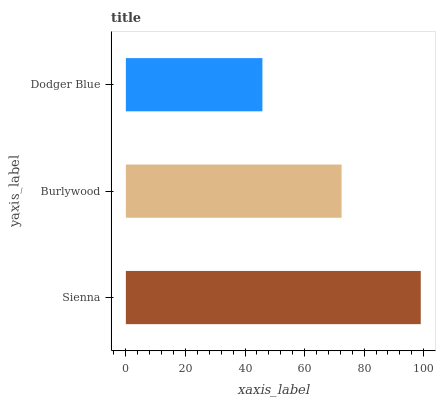Is Dodger Blue the minimum?
Answer yes or no. Yes. Is Sienna the maximum?
Answer yes or no. Yes. Is Burlywood the minimum?
Answer yes or no. No. Is Burlywood the maximum?
Answer yes or no. No. Is Sienna greater than Burlywood?
Answer yes or no. Yes. Is Burlywood less than Sienna?
Answer yes or no. Yes. Is Burlywood greater than Sienna?
Answer yes or no. No. Is Sienna less than Burlywood?
Answer yes or no. No. Is Burlywood the high median?
Answer yes or no. Yes. Is Burlywood the low median?
Answer yes or no. Yes. Is Dodger Blue the high median?
Answer yes or no. No. Is Sienna the low median?
Answer yes or no. No. 